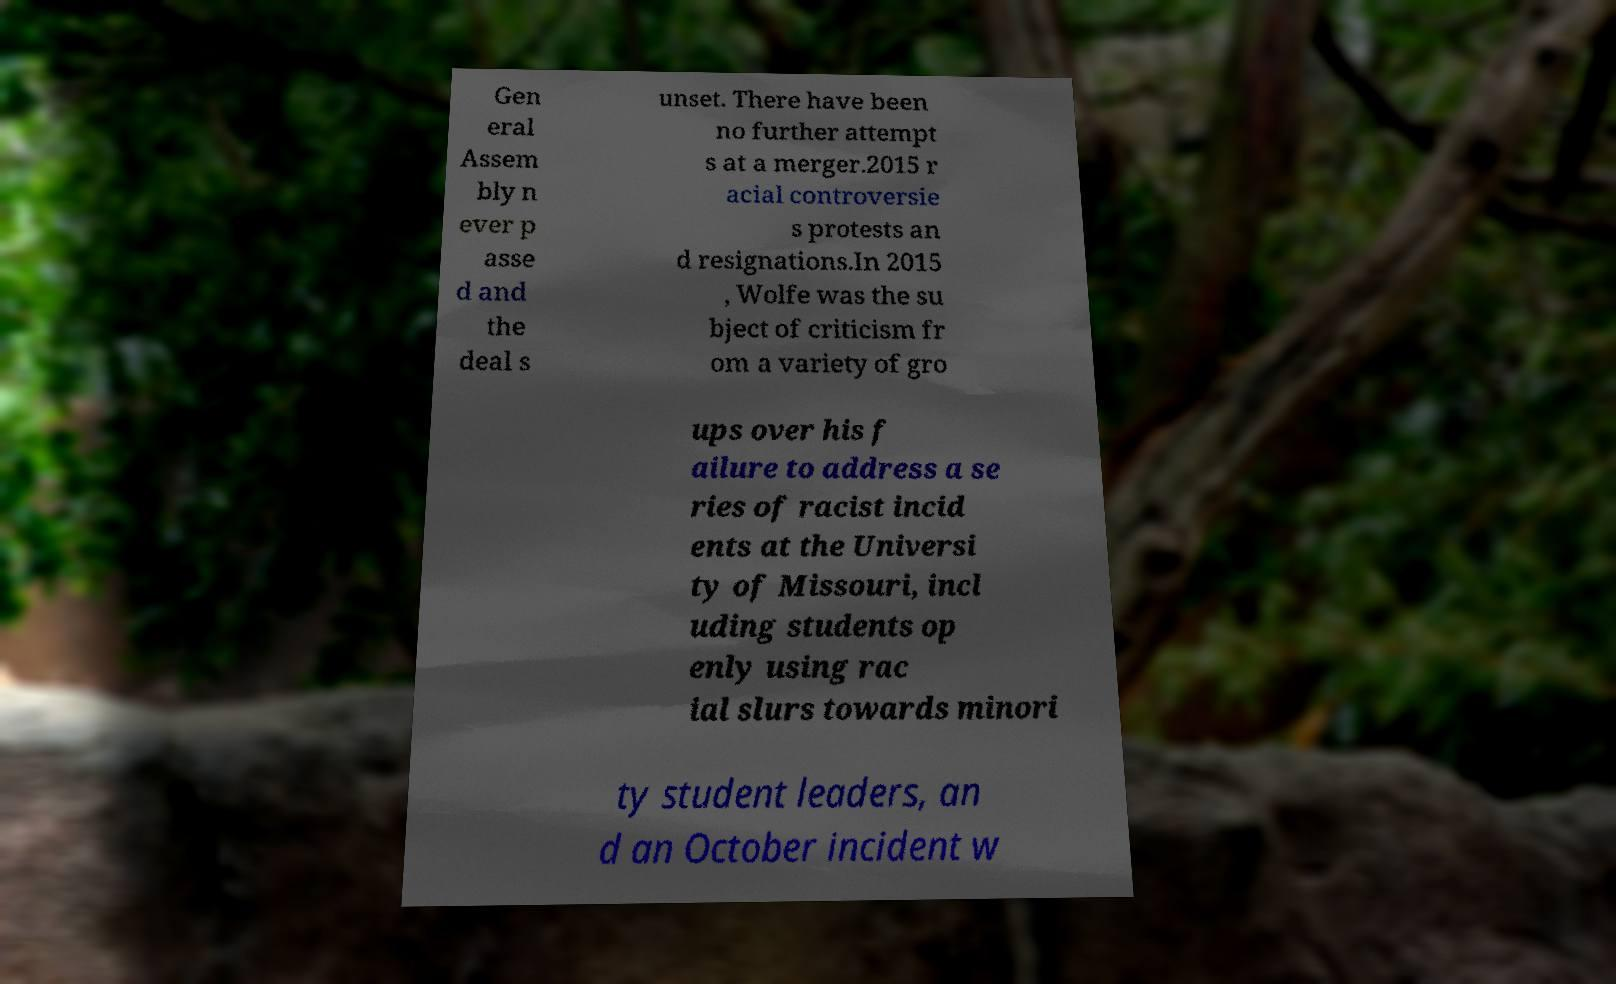Can you accurately transcribe the text from the provided image for me? Gen eral Assem bly n ever p asse d and the deal s unset. There have been no further attempt s at a merger.2015 r acial controversie s protests an d resignations.In 2015 , Wolfe was the su bject of criticism fr om a variety of gro ups over his f ailure to address a se ries of racist incid ents at the Universi ty of Missouri, incl uding students op enly using rac ial slurs towards minori ty student leaders, an d an October incident w 